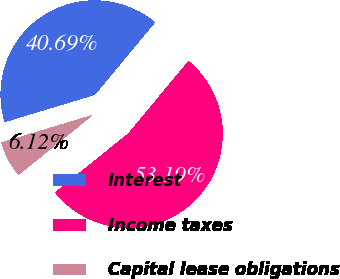Convert chart to OTSL. <chart><loc_0><loc_0><loc_500><loc_500><pie_chart><fcel>Interest<fcel>Income taxes<fcel>Capital lease obligations<nl><fcel>40.69%<fcel>53.19%<fcel>6.12%<nl></chart> 